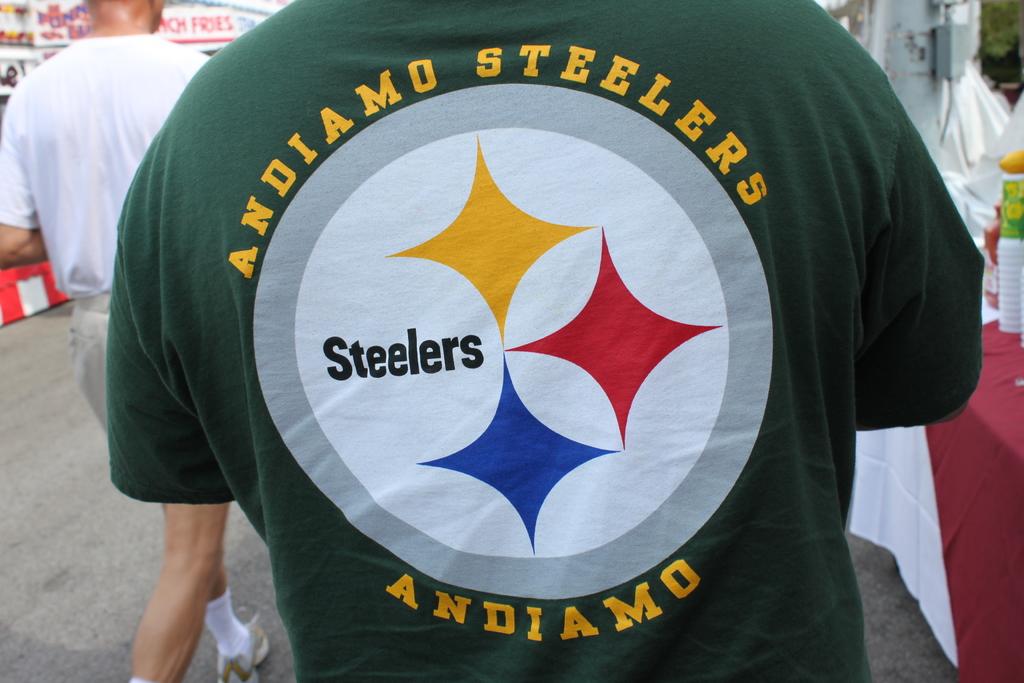What is written at the bottom of his shirt?
Keep it short and to the point. Andiamo. 